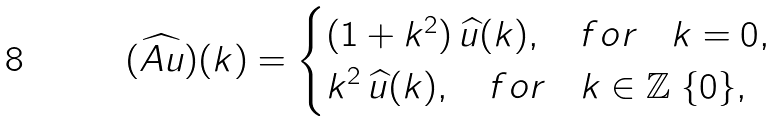Convert formula to latex. <formula><loc_0><loc_0><loc_500><loc_500>( \widehat { A u } ) ( k ) = \begin{cases} ( 1 + k ^ { 2 } ) \, \widehat { u } ( k ) , \quad f o r \quad k = 0 , \\ k ^ { 2 } \, \widehat { u } ( k ) , \quad f o r \quad k \in \mathbb { Z } \ \{ 0 \} , \end{cases}</formula> 